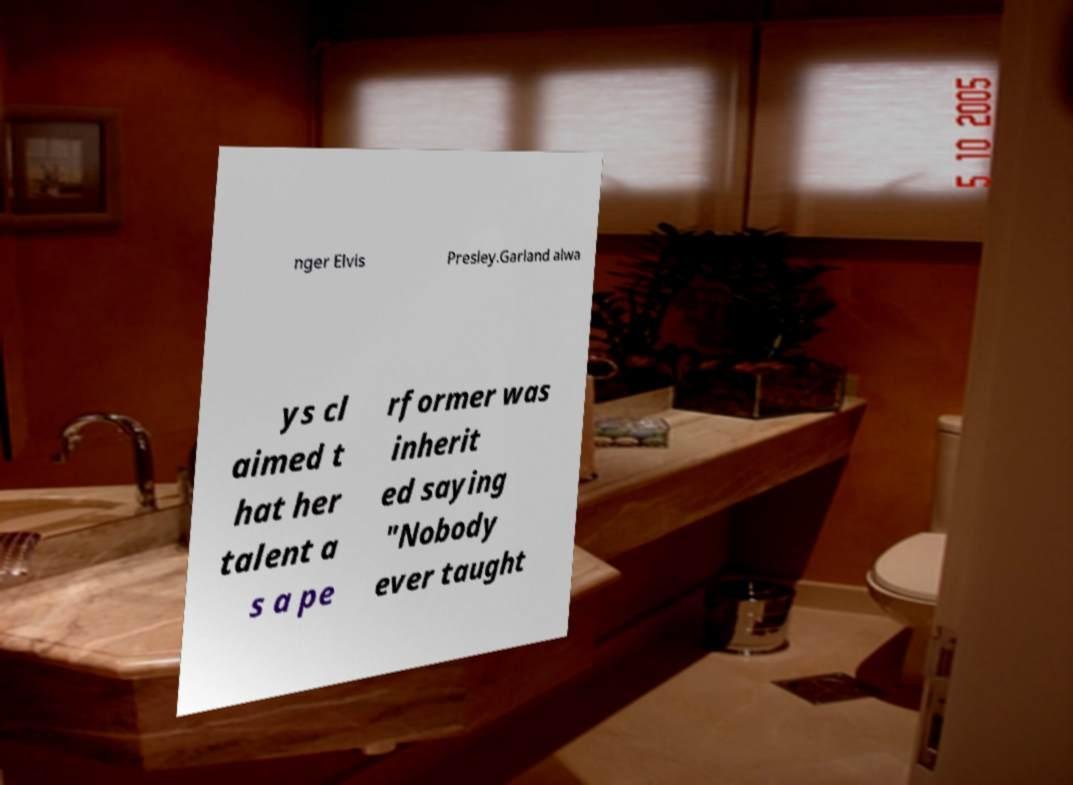Could you extract and type out the text from this image? nger Elvis Presley.Garland alwa ys cl aimed t hat her talent a s a pe rformer was inherit ed saying "Nobody ever taught 